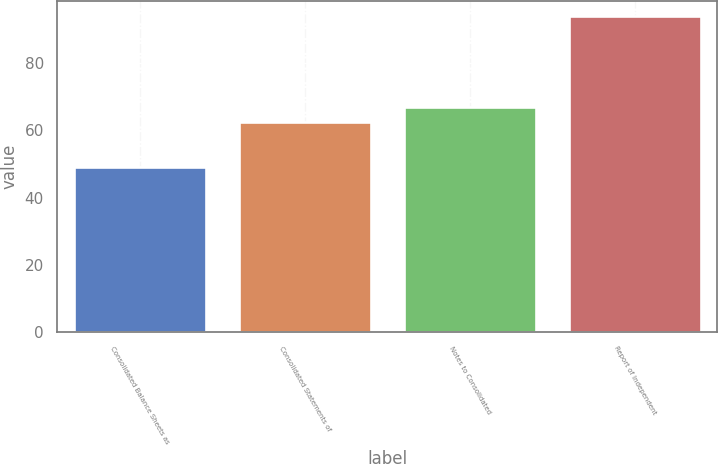Convert chart to OTSL. <chart><loc_0><loc_0><loc_500><loc_500><bar_chart><fcel>Consolidated Balance Sheets as<fcel>Consolidated Statements of<fcel>Notes to Consolidated<fcel>Report of Independent<nl><fcel>49<fcel>62.5<fcel>67<fcel>94<nl></chart> 